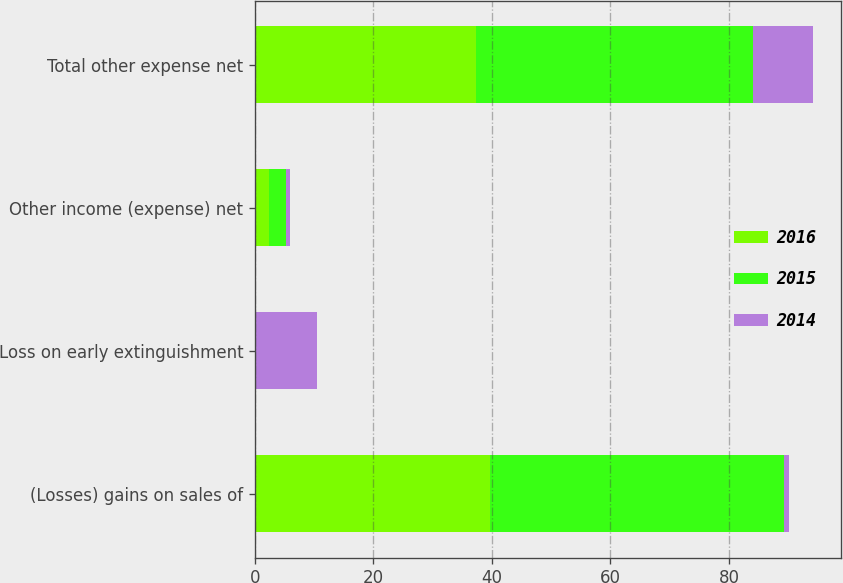<chart> <loc_0><loc_0><loc_500><loc_500><stacked_bar_chart><ecel><fcel>(Losses) gains on sales of<fcel>Loss on early extinguishment<fcel>Other income (expense) net<fcel>Total other expense net<nl><fcel>2016<fcel>39.7<fcel>0<fcel>2.4<fcel>37.3<nl><fcel>2015<fcel>49.6<fcel>0<fcel>2.9<fcel>46.7<nl><fcel>2014<fcel>0.8<fcel>10.4<fcel>0.6<fcel>10.2<nl></chart> 